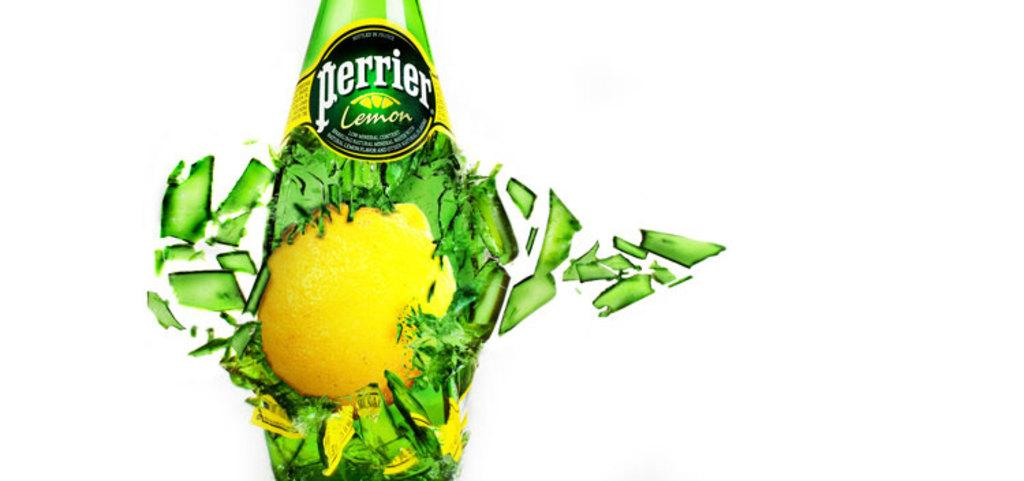What is the main object in the picture? There is a broken bottle in the picture. What color is the bottle? The bottle is green in color. What can be seen inside the bottle? There is a yellow object inside the bottle. What color is the background of the image? The background of the image is white. What type of stem is growing out of the broken bottle in the image? There is no stem growing out of the broken bottle in the image. What range of motion can be observed in the image? There is no motion or movement in the image, so it is not possible to determine a range of motion. 